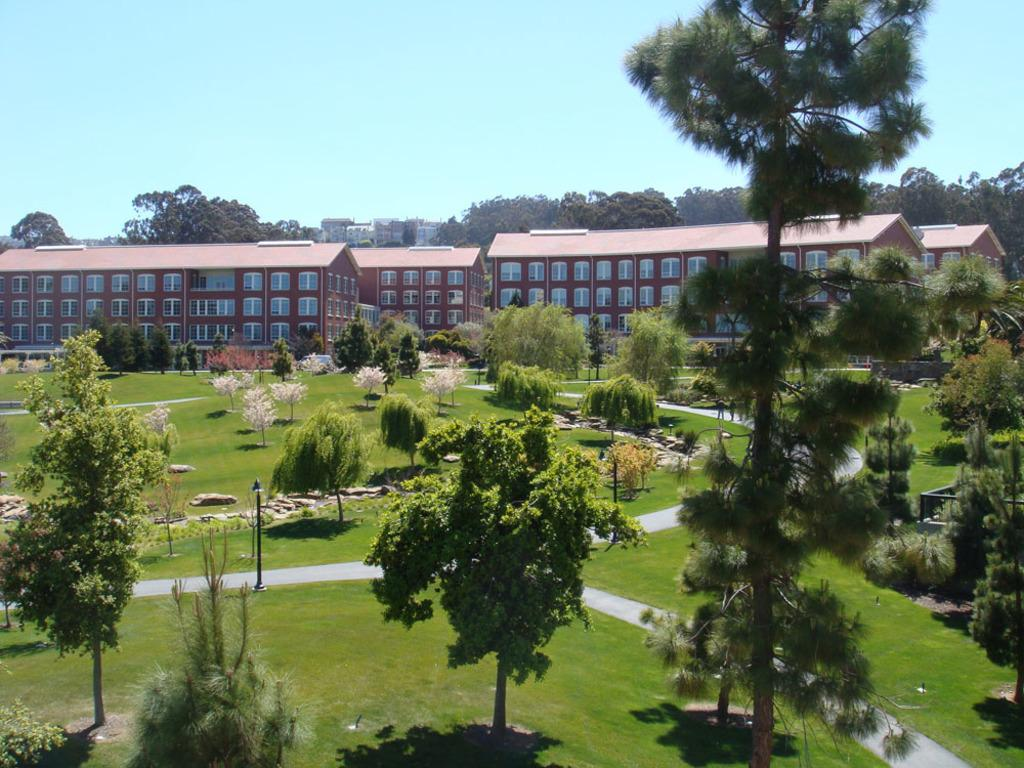What type of vegetation can be seen in the image? There are trees and plants in the image. What other natural elements are present in the image? There are stones and grass in the image. What man-made structures can be seen in the image? There are buildings in the image. What architectural features can be seen on the buildings? There are windows in the image. What part of the natural environment is visible in the image? The sky is visible in the image. Can you see a baseball game happening in the image? There is no baseball game present in the image. What type of rail can be seen connecting the trees in the image? There is no rail connecting the trees in the image; only trees, plants, stones, grass, buildings, windows, and the sky are present. 